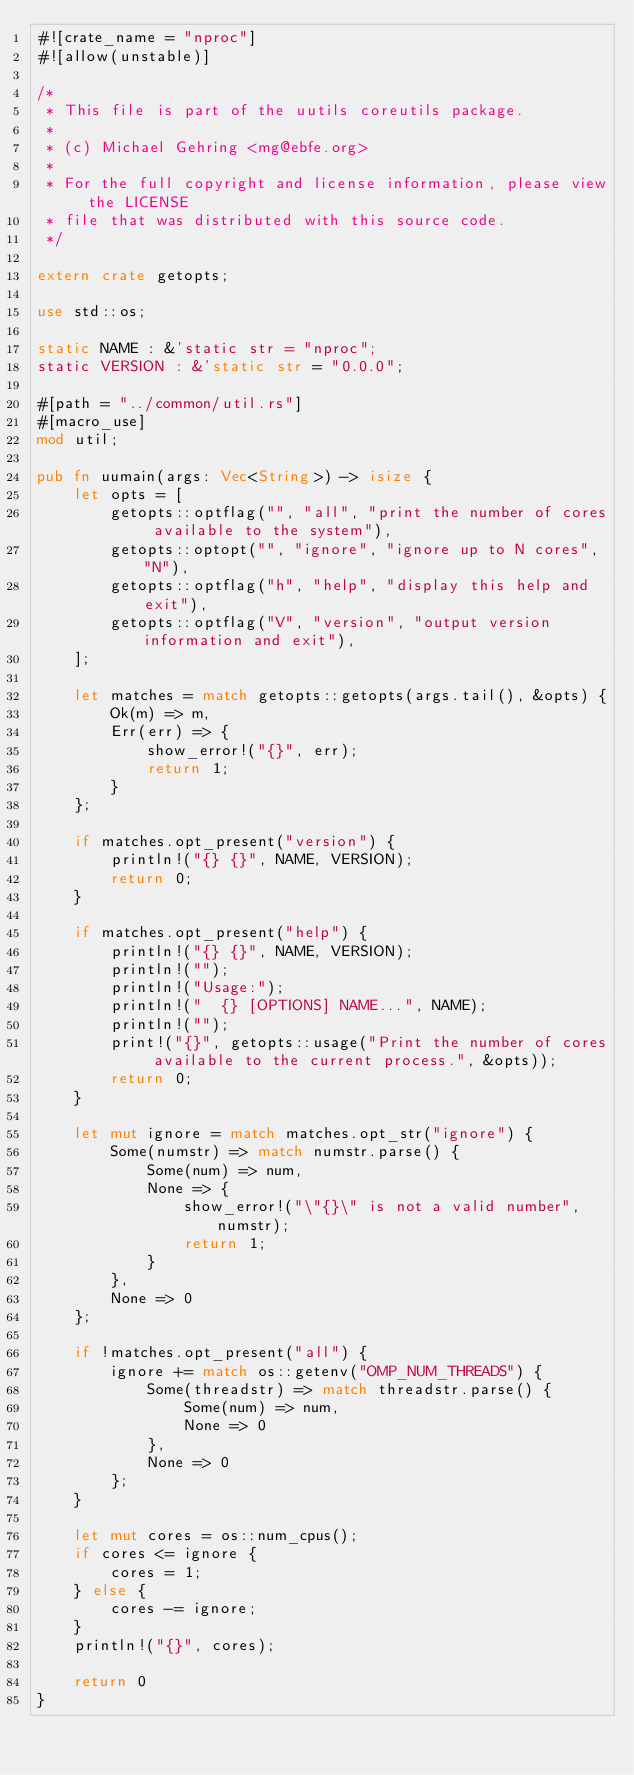<code> <loc_0><loc_0><loc_500><loc_500><_Rust_>#![crate_name = "nproc"]
#![allow(unstable)]

/*
 * This file is part of the uutils coreutils package.
 *
 * (c) Michael Gehring <mg@ebfe.org>
 *
 * For the full copyright and license information, please view the LICENSE
 * file that was distributed with this source code.
 */

extern crate getopts;

use std::os;

static NAME : &'static str = "nproc";
static VERSION : &'static str = "0.0.0";

#[path = "../common/util.rs"]
#[macro_use]
mod util;

pub fn uumain(args: Vec<String>) -> isize {
    let opts = [
        getopts::optflag("", "all", "print the number of cores available to the system"),
        getopts::optopt("", "ignore", "ignore up to N cores", "N"),
        getopts::optflag("h", "help", "display this help and exit"),
        getopts::optflag("V", "version", "output version information and exit"),
    ];

    let matches = match getopts::getopts(args.tail(), &opts) {
        Ok(m) => m,
        Err(err) => {
            show_error!("{}", err);
            return 1;
        }
    };

    if matches.opt_present("version") {
        println!("{} {}", NAME, VERSION);
        return 0;
    }

    if matches.opt_present("help") {
        println!("{} {}", NAME, VERSION);
        println!("");
        println!("Usage:");
        println!("  {} [OPTIONS] NAME...", NAME);
        println!("");
        print!("{}", getopts::usage("Print the number of cores available to the current process.", &opts));
        return 0;
    }

    let mut ignore = match matches.opt_str("ignore") {
        Some(numstr) => match numstr.parse() {
            Some(num) => num,
            None => {
                show_error!("\"{}\" is not a valid number", numstr);
                return 1;
            }
        },
        None => 0
    };

    if !matches.opt_present("all") {
        ignore += match os::getenv("OMP_NUM_THREADS") {
            Some(threadstr) => match threadstr.parse() {
                Some(num) => num,
                None => 0
            },
            None => 0
        };
    }

    let mut cores = os::num_cpus();
    if cores <= ignore {
        cores = 1;
    } else {
        cores -= ignore;
    }
    println!("{}", cores);

    return 0
}
</code> 